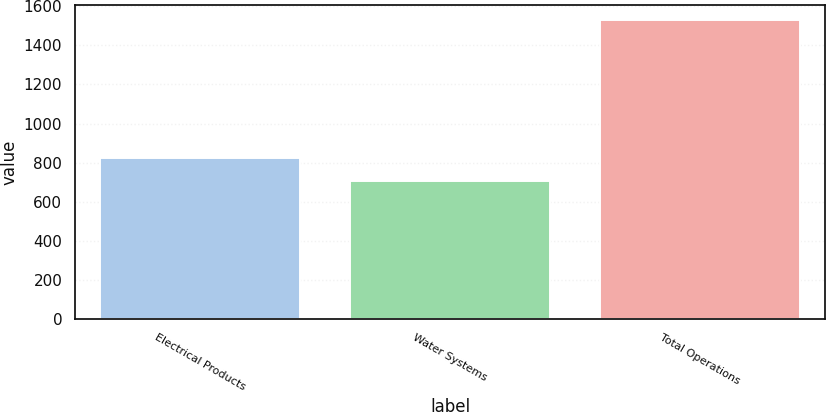Convert chart to OTSL. <chart><loc_0><loc_0><loc_500><loc_500><bar_chart><fcel>Electrical Products<fcel>Water Systems<fcel>Total Operations<nl><fcel>824.6<fcel>706.1<fcel>1530.7<nl></chart> 